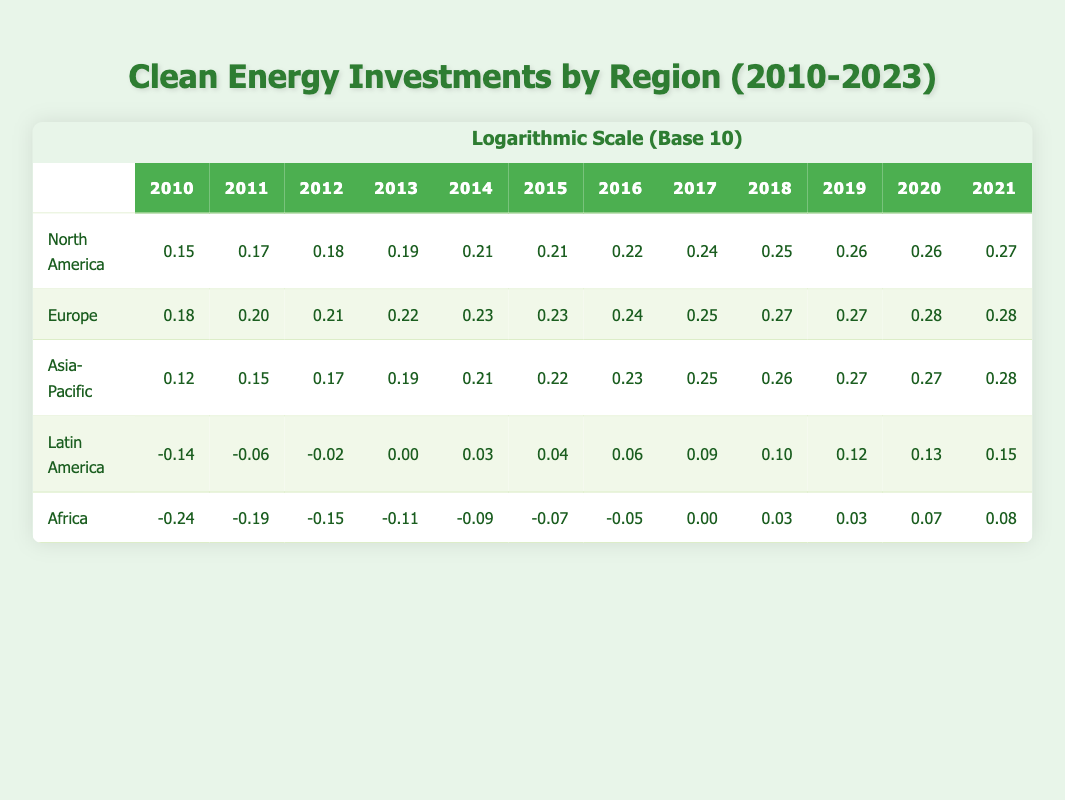What is the total investment in Clean Energy Technologies for Europe in 2023? The table shows the investment for Europe in 2023 as 95.4. This is directly retrieved from the corresponding cell in the table for the year 2023 under the Europe row.
Answer: 95.4 Which region had the highest investment in Clean Energy Technologies in 2010? By comparing the values for each region in 2010, North America had an investment of 25.4, Europe 34.2, Asia-Pacific 20.5, Latin America 5.3, and Africa 3.7. Therefore, the highest investment was in Europe.
Answer: Europe What is the increase in investment for Latin America from 2010 to 2023? The investment for Latin America in 2010 was 5.3, and in 2023 it was 30.2. The increase is calculated by subtracting 5.3 from 30.2, which gives 30.2 - 5.3 = 24.9.
Answer: 24.9 Is the investment in Clean Energy Technologies for Africa in 2015 greater than that for Latin America in the same year? The investment for Africa in 2015 was 7.3, while Latin America’s investment was 12.4. Comparing these values, 7.3 is not greater than 12.4. Hence, the statement is false.
Answer: No What is the average investment in Clean Energy Technologies for Asia-Pacific from 2010 to 2023? To find the average, sum the investments from 2010 to 2023 (1.31 + 1.41 + 1.48 + 1.55 + 1.61 + 1.65 + 1.70 + 1.77 + 1.81 + 1.85 + 1.88 + 1.92 + 1.95 + 1.98) = 23.22. There are 14 data points, so the average investment is 23.22 / 14 = 1.66 (rounded to two decimal points).
Answer: 1.66 In which year did North America see its largest increase in Clean Energy investment? By examining the annual investments for North America from 2010 to 2023, the largest increase occurred between 2016 (44.9) and 2017 (55.3). The difference is 55.3 - 44.9 = 10.4, which is the largest change.
Answer: 2017 How much more did Europe invest in Clean Energy Technologies compared to Africa in 2022? The investments in 2022 are 90.5 for Europe and 17.8 for Africa. The difference is calculated by subtracting Africa's investment from Europe's: 90.5 - 17.8 = 72.7.
Answer: 72.7 Which region had a constant increase in Clean Energy investments every year from 2010 to 2023? Observing the data for all regions, Latin America shows a steady increase each year without any decrease or stagnation, which indicates a consistent growth pattern.
Answer: Latin America 